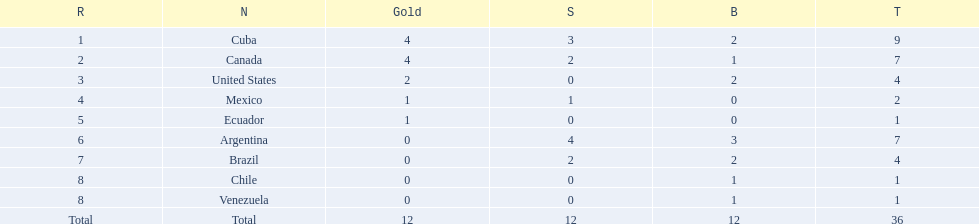Which countries have won gold medals? Cuba, Canada, United States, Mexico, Ecuador. Of these countries, which ones have never won silver or bronze medals? United States, Ecuador. Of the two nations listed previously, which one has only won a gold medal? Ecuador. 